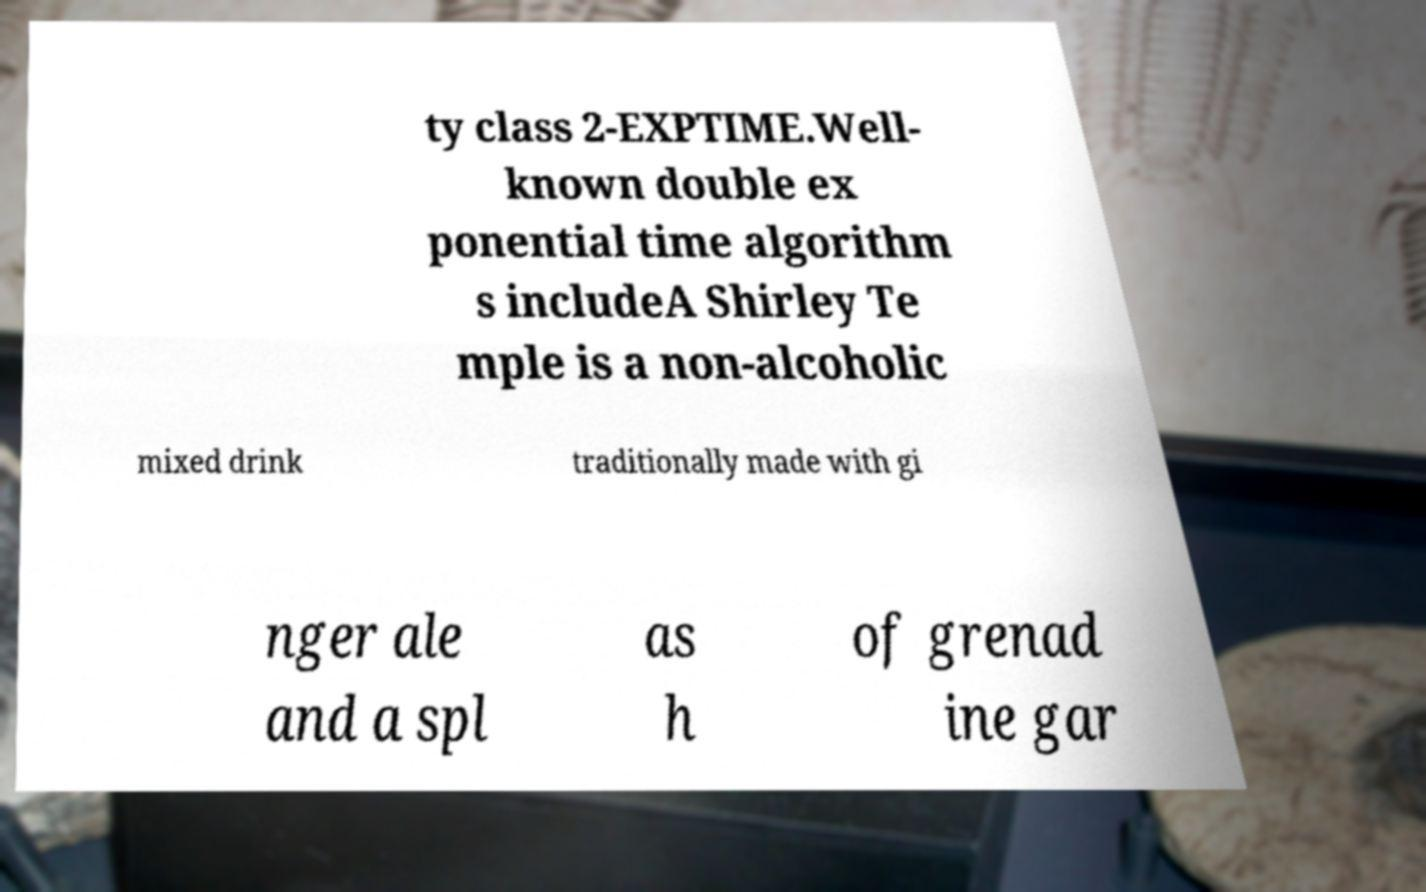Please read and relay the text visible in this image. What does it say? ty class 2-EXPTIME.Well- known double ex ponential time algorithm s includeA Shirley Te mple is a non-alcoholic mixed drink traditionally made with gi nger ale and a spl as h of grenad ine gar 